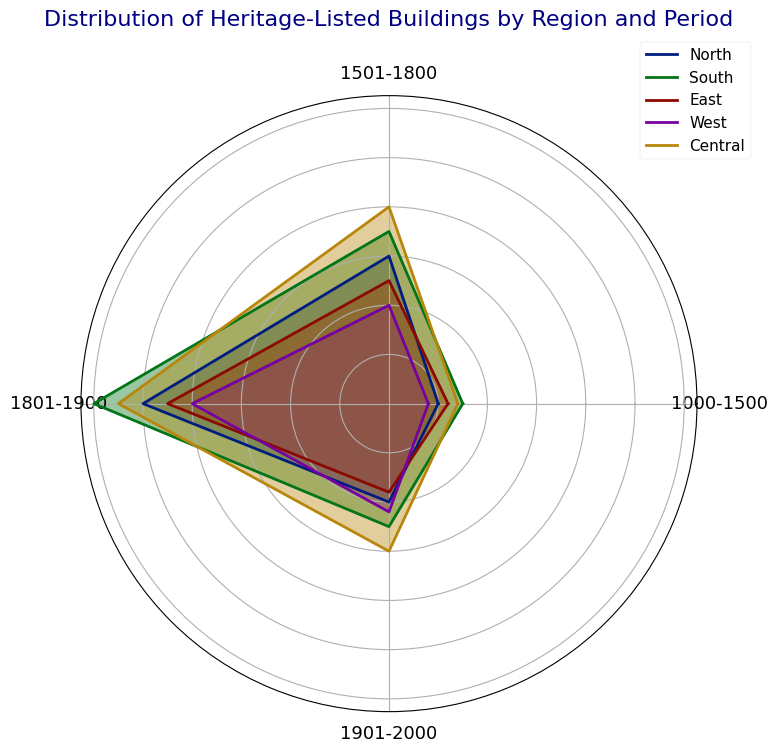Which region has the highest number of heritage-listed buildings from 1501-1800? By examining the radar chart, look at the value corresponding to 1501-1800 for each region and identify the highest value. The Central region has the highest value of 40.
Answer: Central Which region has the lowest number of heritage-listed buildings from 1901-2000? By examining the radar chart, look at the value corresponding to 1901-2000 for each region and identify the lowest value. The East region has the lowest value of 18.
Answer: East What is the difference in the number of heritage-listed buildings from 1000-1500 between the North and South regions? Find the 1000-1500 value for both North (10) and South (15) on the radar chart. Subtract the smaller value from the larger one: 15 - 10 = 5.
Answer: 5 Sum the number of heritage-listed buildings from 1801-1900 for all regions. Add the values from 1801-1900 for each region: North (50) + South (60) + East (45) + West (40) + Central (55) = 250.
Answer: 250 Which region shows the most variation in the number of heritage-listed buildings across different periods? Examine the radar chart to see which region's shape is the most irregular, indicating higher variability. The South region shows the greatest variation.
Answer: South Which period has the highest overall number of heritage-listed buildings when considering all regions together? Sum the values for each period across all regions and compare: 1000-1500 (59), 1501-1800 (150), 1801-1900 (250), 1901-2000 (115). The period 1801-1900 has the highest total.
Answer: 1801-1900 Do more regions have higher values for heritage-listed buildings in 1501-1800 or 1901-2000? Compare the number of regions where the values for 1501-1800 exceed that of 1901-2000. Two regions (South and Central) have higher values in 1501-1800 compared to one region in 1901-2000 (North).
Answer: 1501-1800 Which region has the closest number of heritage-listed buildings between 1801-1900 and 1901-2000? Compare the values of 1801-1900 and 1901-2000 for each region and find the smallest difference. The West region has 40 in 1801-1900 and 22 in 1901-2000, making the difference 18, which is the closest among all regions.
Answer: West 